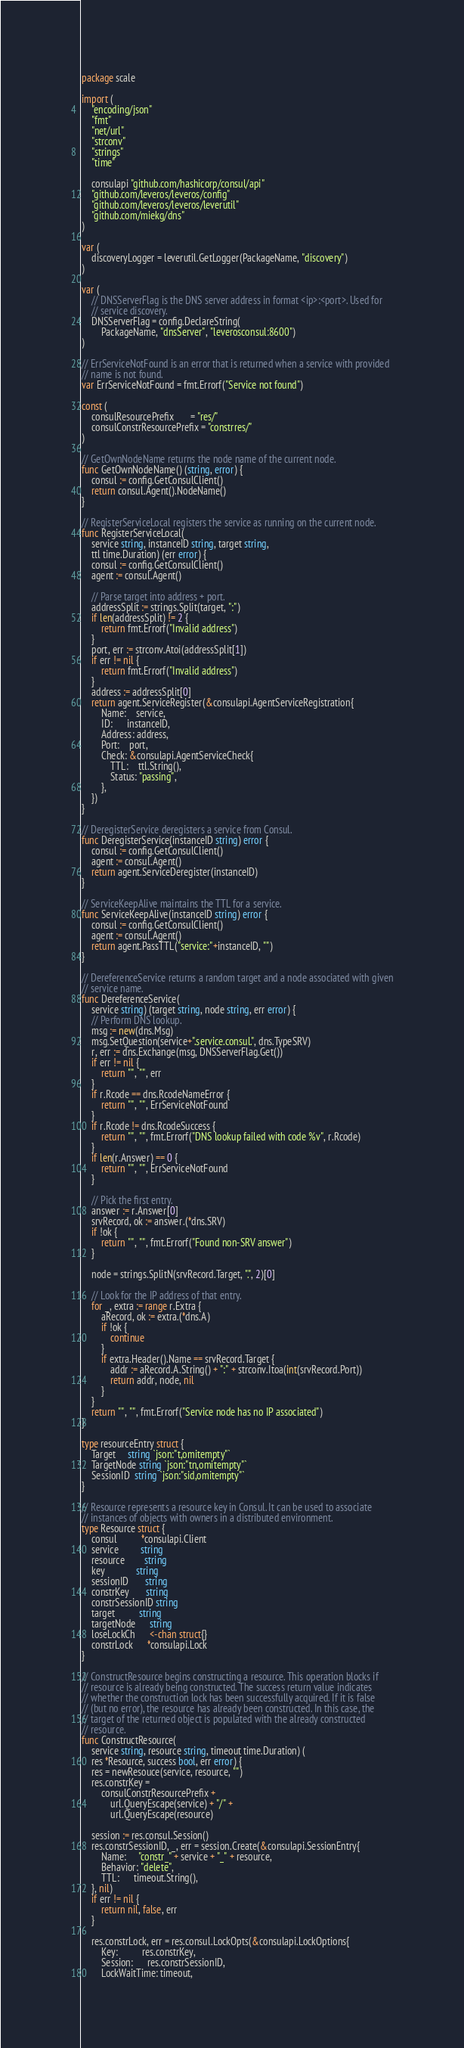Convert code to text. <code><loc_0><loc_0><loc_500><loc_500><_Go_>package scale

import (
	"encoding/json"
	"fmt"
	"net/url"
	"strconv"
	"strings"
	"time"

	consulapi "github.com/hashicorp/consul/api"
	"github.com/leveros/leveros/config"
	"github.com/leveros/leveros/leverutil"
	"github.com/miekg/dns"
)

var (
	discoveryLogger = leverutil.GetLogger(PackageName, "discovery")
)

var (
	// DNSServerFlag is the DNS server address in format <ip>:<port>. Used for
	// service discovery.
	DNSServerFlag = config.DeclareString(
		PackageName, "dnsServer", "leverosconsul:8600")
)

// ErrServiceNotFound is an error that is returned when a service with provided
// name is not found.
var ErrServiceNotFound = fmt.Errorf("Service not found")

const (
	consulResourcePrefix       = "res/"
	consulConstrResourcePrefix = "constrres/"
)

// GetOwnNodeName returns the node name of the current node.
func GetOwnNodeName() (string, error) {
	consul := config.GetConsulClient()
	return consul.Agent().NodeName()
}

// RegisterServiceLocal registers the service as running on the current node.
func RegisterServiceLocal(
	service string, instanceID string, target string,
	ttl time.Duration) (err error) {
	consul := config.GetConsulClient()
	agent := consul.Agent()

	// Parse target into address + port.
	addressSplit := strings.Split(target, ":")
	if len(addressSplit) != 2 {
		return fmt.Errorf("Invalid address")
	}
	port, err := strconv.Atoi(addressSplit[1])
	if err != nil {
		return fmt.Errorf("Invalid address")
	}
	address := addressSplit[0]
	return agent.ServiceRegister(&consulapi.AgentServiceRegistration{
		Name:    service,
		ID:      instanceID,
		Address: address,
		Port:    port,
		Check: &consulapi.AgentServiceCheck{
			TTL:    ttl.String(),
			Status: "passing",
		},
	})
}

// DeregisterService deregisters a service from Consul.
func DeregisterService(instanceID string) error {
	consul := config.GetConsulClient()
	agent := consul.Agent()
	return agent.ServiceDeregister(instanceID)
}

// ServiceKeepAlive maintains the TTL for a service.
func ServiceKeepAlive(instanceID string) error {
	consul := config.GetConsulClient()
	agent := consul.Agent()
	return agent.PassTTL("service:"+instanceID, "")
}

// DereferenceService returns a random target and a node associated with given
// service name.
func DereferenceService(
	service string) (target string, node string, err error) {
	// Perform DNS lookup.
	msg := new(dns.Msg)
	msg.SetQuestion(service+".service.consul.", dns.TypeSRV)
	r, err := dns.Exchange(msg, DNSServerFlag.Get())
	if err != nil {
		return "", "", err
	}
	if r.Rcode == dns.RcodeNameError {
		return "", "", ErrServiceNotFound
	}
	if r.Rcode != dns.RcodeSuccess {
		return "", "", fmt.Errorf("DNS lookup failed with code %v", r.Rcode)
	}
	if len(r.Answer) == 0 {
		return "", "", ErrServiceNotFound
	}

	// Pick the first entry.
	answer := r.Answer[0]
	srvRecord, ok := answer.(*dns.SRV)
	if !ok {
		return "", "", fmt.Errorf("Found non-SRV answer")
	}

	node = strings.SplitN(srvRecord.Target, ".", 2)[0]

	// Look for the IP address of that entry.
	for _, extra := range r.Extra {
		aRecord, ok := extra.(*dns.A)
		if !ok {
			continue
		}
		if extra.Header().Name == srvRecord.Target {
			addr := aRecord.A.String() + ":" + strconv.Itoa(int(srvRecord.Port))
			return addr, node, nil
		}
	}
	return "", "", fmt.Errorf("Service node has no IP associated")
}

type resourceEntry struct {
	Target     string `json:"t,omitempty"`
	TargetNode string `json:"tn,omitempty"`
	SessionID  string `json:"sid,omitempty"`
}

// Resource represents a resource key in Consul. It can be used to associate
// instances of objects with owners in a distributed environment.
type Resource struct {
	consul          *consulapi.Client
	service         string
	resource        string
	key             string
	sessionID       string
	constrKey       string
	constrSessionID string
	target          string
	targetNode      string
	loseLockCh      <-chan struct{}
	constrLock      *consulapi.Lock
}

// ConstructResource begins constructing a resource. This operation blocks if
// resource is already being constructed. The success return value indicates
// whether the construction lock has been successfully acquired. If it is false
// (but no error), the resource has already been constructed. In this case, the
// target of the returned object is populated with the already constructed
// resource.
func ConstructResource(
	service string, resource string, timeout time.Duration) (
	res *Resource, success bool, err error) {
	res = newResouce(service, resource, "")
	res.constrKey =
		consulConstrResourcePrefix +
			url.QueryEscape(service) + "/" +
			url.QueryEscape(resource)

	session := res.consul.Session()
	res.constrSessionID, _, err = session.Create(&consulapi.SessionEntry{
		Name:     "constr_" + service + "_" + resource,
		Behavior: "delete",
		TTL:      timeout.String(),
	}, nil)
	if err != nil {
		return nil, false, err
	}

	res.constrLock, err = res.consul.LockOpts(&consulapi.LockOptions{
		Key:          res.constrKey,
		Session:      res.constrSessionID,
		LockWaitTime: timeout,</code> 